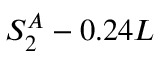Convert formula to latex. <formula><loc_0><loc_0><loc_500><loc_500>S _ { 2 } ^ { A } - 0 . 2 4 L</formula> 